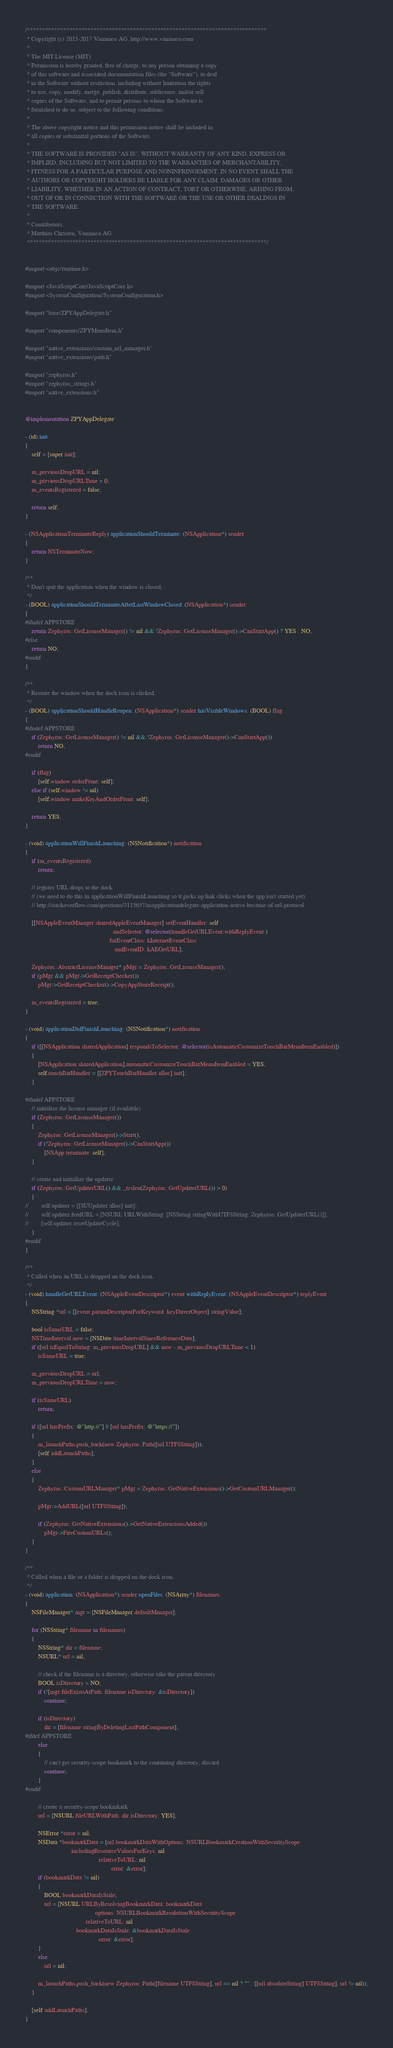<code> <loc_0><loc_0><loc_500><loc_500><_ObjectiveC_>/*******************************************************************************
 * Copyright (c) 2015-2017 Vanamco AG, http://www.vanamco.com
 *
 * The MIT License (MIT)
 * Permission is hereby granted, free of charge, to any person obtaining a copy
 * of this software and associated documentation files (the "Software"), to deal
 * in the Software without restriction, including without limitation the rights
 * to use, copy, modify, merge, publish, distribute, sublicense, and/or sell
 * copies of the Software, and to permit persons to whom the Software is
 * furnished to do so, subject to the following conditions:
 *
 * The above copyright notice and this permission notice shall be included in
 * all copies or substantial portions of the Software.
 *
 * THE SOFTWARE IS PROVIDED "AS IS", WITHOUT WARRANTY OF ANY KIND, EXPRESS OR
 * IMPLIED, INCLUDING BUT NOT LIMITED TO THE WARRANTIES OF MERCHANTABILITY,
 * FITNESS FOR A PARTICULAR PURPOSE AND NONINFRINGEMENT. IN NO EVENT SHALL THE
 * AUTHORS OR COPYRIGHT HOLDERS BE LIABLE FOR ANY CLAIM, DAMAGES OR OTHER
 * LIABILITY, WHETHER IN AN ACTION OF CONTRACT, TORT OR OTHERWISE, ARISING FROM,
 * OUT OF OR IN CONNECTION WITH THE SOFTWARE OR THE USE OR OTHER DEALINGS IN
 * THE SOFTWARE.
 *
 * Contributors:
 * Matthias Christen, Vanamco AG
 *******************************************************************************/


#import <objc/runtime.h>

#import <JavaScriptCore/JavaScriptCore.h>
#import <SystemConfiguration/SystemConfiguration.h>

#import "base/ZPYAppDelegate.h"

#import "components/ZPYMenuItem.h"

#import "native_extensions/custom_url_manager.h"
#import "native_extensions/path.h"

#import "zephyros.h"
#import "zephyros_strings.h"
#import "native_extensions.h"


@implementation ZPYAppDelegate

- (id) init
{
    self = [super init];
    
    m_previousDropURL = nil;
    m_previousDropURLTime = 0;
    m_eventsRegistered = false;

    return self;
}

- (NSApplicationTerminateReply) applicationShouldTerminate: (NSApplication*) sender
{
    return NSTerminateNow;
}

/**
 * Don't quit the application when the window is closed.
 */
- (BOOL) applicationShouldTerminateAfterLastWindowClosed: (NSApplication*) sender
{
#ifndef APPSTORE
    return Zephyros::GetLicenseManager() != nil && !Zephyros::GetLicenseManager()->CanStartApp() ? YES : NO;
#else
    return NO;
#endif
}

/**
 * Restore the window when the dock icon is clicked.
 */
- (BOOL) applicationShouldHandleReopen: (NSApplication*) sender hasVisibleWindows: (BOOL) flag
{
#ifndef APPSTORE
    if (Zephyros::GetLicenseManager() != nil && !Zephyros::GetLicenseManager()->CanStartApp())
        return NO;
#endif
    
    if (flag)
        [self.window orderFront: self];
    else if (self.window != nil)
        [self.window makeKeyAndOrderFront: self];
    
    return YES;
}

- (void) applicationWillFinishLaunching: (NSNotification*) notification
{
    if (m_eventsRegistered)
        return;

    // register URL drops to the dock
    // (we need to do this in applicationWillFinishLaunching so it picks up link clicks when the app isn't started yet)
    // http://stackoverflow.com/questions/3115657/nsapplicationdelegate-application-active-because-of-url-protocol

    [[NSAppleEventManager sharedAppleEventManager] setEventHandler: self
                                                       andSelector: @selector(handleGetURLEvent:withReplyEvent:)
                                                     forEventClass: kInternetEventClass
                                                        andEventID: kAEGetURL];

    Zephyros::AbstractLicenseManager* pMgr = Zephyros::GetLicenseManager();
    if (pMgr && pMgr->GetReceiptChecker())
        pMgr->GetReceiptChecker()->CopyAppStoreReceipt();
    
    m_eventsRegistered = true;
}

- (void) applicationDidFinishLaunching: (NSNotification*) notification
{
    if ([[NSApplication sharedApplication] respondsToSelector: @selector(isAutomaticCustomizeTouchBarMenuItemEnabled)])
    {
        [NSApplication sharedApplication].automaticCustomizeTouchBarMenuItemEnabled = YES;
        self.touchBarHandler = [[ZPYTouchBarHandler alloc] init];
    }

#ifndef APPSTORE
    // initialize the license manager (if available)
    if (Zephyros::GetLicenseManager())
    {
        Zephyros::GetLicenseManager()->Start();
        if (!Zephyros::GetLicenseManager()->CanStartApp())
            [NSApp terminate: self];
    }

    // create and initialize the updater
    if (Zephyros::GetUpdaterURL() && _tcslen(Zephyros::GetUpdaterURL()) > 0)
    {
//        self.updater = [[SUUpdater alloc] init];
//        self.updater.feedURL = [NSURL URLWithString: [NSString stringWithUTF8String: Zephyros::GetUpdaterURL()]];
//        [self.updater resetUpdateCycle];
    }
#endif
}

/**
 * Called when an URL is dropped on the dock icon.
 */
- (void) handleGetURLEvent: (NSAppleEventDescriptor*) event withReplyEvent: (NSAppleEventDescriptor*) replyEvent
{
    NSString *url = [[event paramDescriptorForKeyword: keyDirectObject] stringValue];
    
    bool isSameURL = false;
    NSTimeInterval now = [NSDate timeIntervalSinceReferenceDate];
    if ([url isEqualToString: m_previousDropURL] && now - m_previousDropURLTime < 1)
        isSameURL = true;

    m_previousDropURL = url;
    m_previousDropURLTime = now;

    if (isSameURL)
        return;
    
    if ([url hasPrefix: @"http://"] || [url hasPrefix: @"https://"])
    {
        m_launchPaths.push_back(new Zephyros::Path([url UTF8String]));
        [self addLaunchPaths];
    }
    else
    {
        Zephyros::CustomURLManager* pMgr = Zephyros::GetNativeExtensions()->GetCustomURLManager();
        
        pMgr->AddURL([url UTF8String]);

        if (Zephyros::GetNativeExtensions()->GetNativeExtensionsAdded())
            pMgr->FireCustomURLs();
    }
}

/**
 * Called when a file or a folder is dropped on the dock icon.
 */
- (void) application: (NSApplication*) sender openFiles: (NSArray*) filenames
{
    NSFileManager* mgr = [NSFileManager defaultManager];
    
    for (NSString* filename in filenames)
    {
        NSString* dir = filename;
        NSURL* url = nil;
        
        // check if the filename is a directory, otherwise take the parent directory
        BOOL isDirectory = NO;
        if (![mgr fileExistsAtPath: filename isDirectory: &isDirectory])
            continue;
        
        if (isDirectory)
            dir = [filename stringByDeletingLastPathComponent];
#ifdef APPSTORE
        else
        {
            // can't get security-scope bookmark to the containing directory; discard
            continue;
        }
#endif
        
        // create a security-scope bookmkark
        url = [NSURL fileURLWithPath: dir isDirectory: YES];
        
        NSError *error = nil;
        NSData *bookmarkData = [url bookmarkDataWithOptions: NSURLBookmarkCreationWithSecurityScope
                             includingResourceValuesForKeys: nil
                                              relativeToURL: nil
                                                      error: &error];
        if (bookmarkData != nil)
        {
            BOOL bookmarkDataIsStale;
            url = [NSURL URLByResolvingBookmarkData: bookmarkData
                                            options: NSURLBookmarkResolutionWithSecurityScope
                                      relativeToURL: nil
                                bookmarkDataIsStale: &bookmarkDataIsStale
                                              error: &error];
        }
        else
            url = nil;
        
        m_launchPaths.push_back(new Zephyros::Path([filename UTF8String], url == nil ? "" : [[url absoluteString] UTF8String], url != nil));
    }
    
    [self addLaunchPaths];
}
</code> 